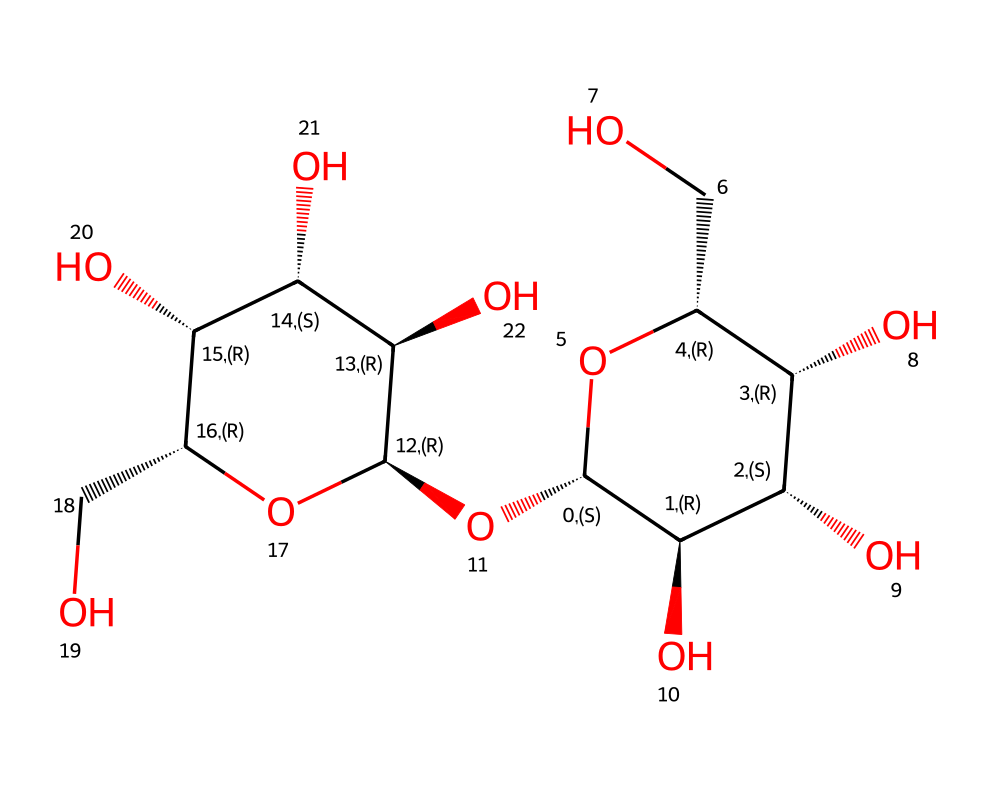What is the main type of carbohydrate represented in this structure? The structure has numerous hydroxyl (OH) groups and consists of glucose units linked by glycosidic bonds, characteristic of cellulose, which is a polysaccharide.
Answer: cellulose How many carbon atoms are present in the structure? Counting the carbons in the structure, there are a total of 6 carbon atoms in each glucose unit, and there appear to be multiple units present. However, specifically, if you look closely, the structure suggests it contains 3 linked glucose units, amounting to 18 carbon atoms total.
Answer: 18 What functional groups are present in this chemical structure? The structure shows multiple hydroxyl (OH) groups and forms a polymeric carbohydrate characteristic of cellulose. The presence of these hydroxyl groups is significant for forming hydrogen bonds, granting cellulose its structural properties.
Answer: hydroxyl groups Is this structure branched or linear? The SMILES representation does not contain branching chains or side groups, indicating that the polymer is comprised of straight chains of glucose units. This is typical of cellulose, which has linear chains for rigidity.
Answer: linear What property of cellulose contributes to the texture of traditional Lebanese bread? The linear structure of cellulose allows for tight packing and forms strong fibers, contributing to the elasticity and structure of the bread, making it chewy and firm, which is desired in traditional Lebanese recipes.
Answer: elasticity 